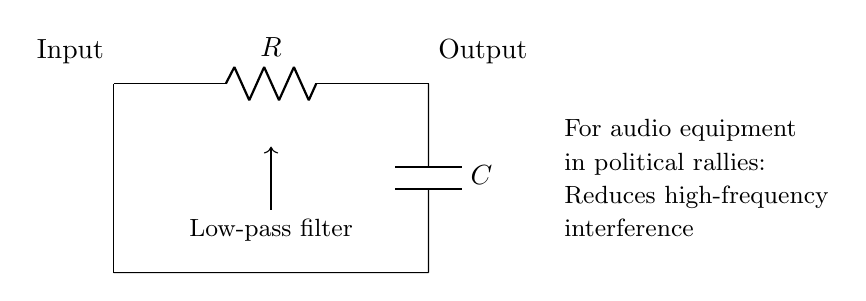What type of filter is shown in the circuit? The circuit is labeled as a "Low-pass filter," which specifically allows low-frequency signals to pass while attenuating high-frequency signals.
Answer: Low-pass filter What are the two main components in this circuit? The circuit diagram shows a resistor and a capacitor connected in a particular configuration, which are the fundamental components of the low-pass filter.
Answer: Resistor and capacitor What is the function of the capacitor in this circuit? The capacitor in a low-pass filter configuration stores and releases energy, determining the cutoff frequency of the filter, and assists in blocking high-frequency signals while allowing lower frequencies to pass.
Answer: Blocks high-frequency signals How many components are used in this low-pass filter circuit? By counting the visible components in the circuit diagram, there are two main components: a resistor and a capacitor.
Answer: Two What is the purpose of this low-pass filter in audio equipment for political rallies? The filter's purpose is described in the circuit diagram as reducing high-frequency interference, which helps improve audio clarity during political rallies where clear communication is crucial.
Answer: Reduces high-frequency interference What determines the cutoff frequency of this low-pass filter? The cutoff frequency is determined by the values of the resistor and capacitor, as their combined effect in the circuit defines the frequency at which the output begins to diminish significantly.
Answer: The resistor and capacitor values What type of connection is shown for the input and output of the circuit? The input and output are indicated by short lines, showing direct connections, which indicates no complex circuitry; it's a straightforward signal flow from input to output through the filter components.
Answer: Short connection lines 